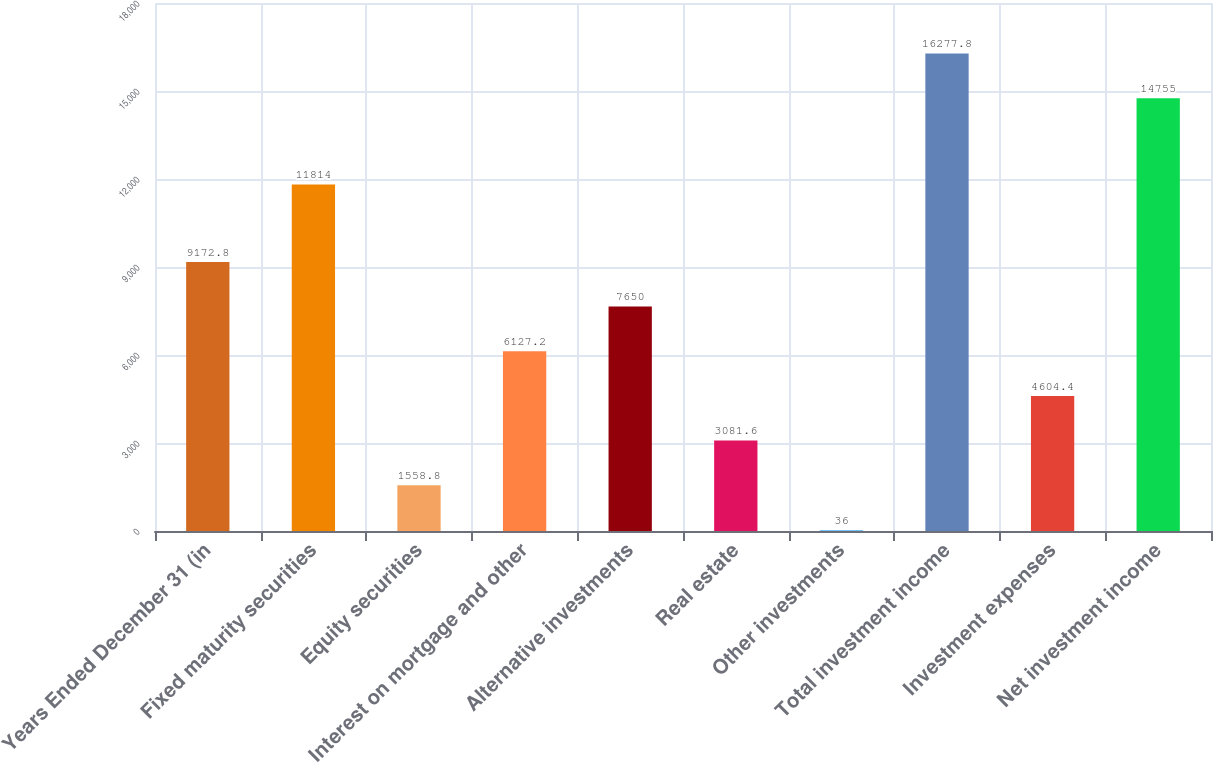Convert chart. <chart><loc_0><loc_0><loc_500><loc_500><bar_chart><fcel>Years Ended December 31 (in<fcel>Fixed maturity securities<fcel>Equity securities<fcel>Interest on mortgage and other<fcel>Alternative investments<fcel>Real estate<fcel>Other investments<fcel>Total investment income<fcel>Investment expenses<fcel>Net investment income<nl><fcel>9172.8<fcel>11814<fcel>1558.8<fcel>6127.2<fcel>7650<fcel>3081.6<fcel>36<fcel>16277.8<fcel>4604.4<fcel>14755<nl></chart> 